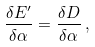Convert formula to latex. <formula><loc_0><loc_0><loc_500><loc_500>\frac { \delta E ^ { \prime } } { \delta \alpha } = \frac { \delta D } { \delta \alpha } \, ,</formula> 